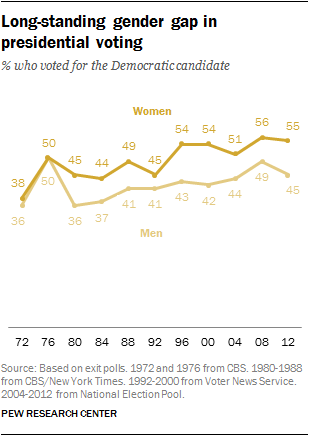Outline some significant characteristics in this image. In 1996, there was a significant difference in the voting preferences of male and female voters for the Democratic candidate. The overlapping value of the two lines is 50. 